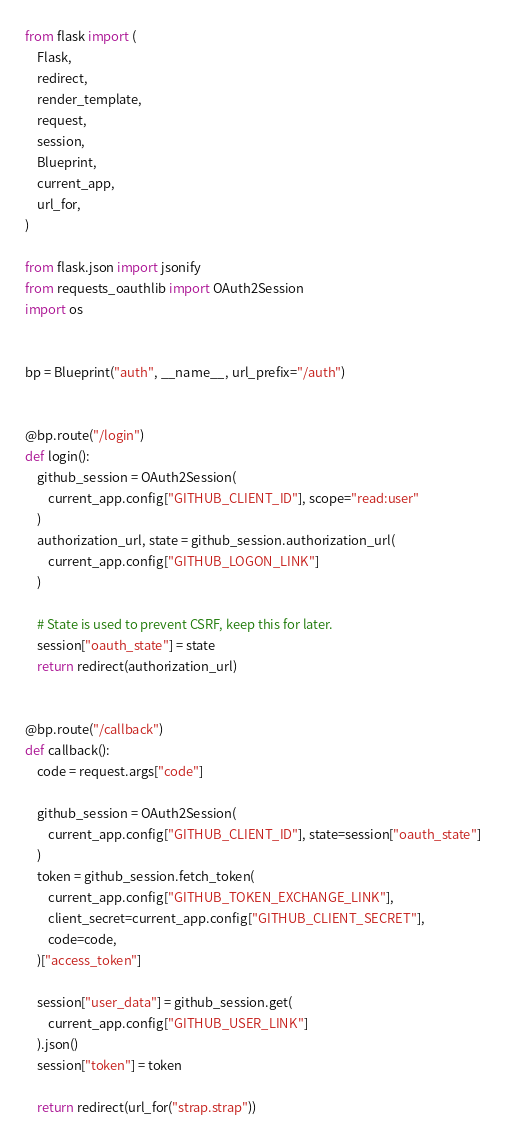<code> <loc_0><loc_0><loc_500><loc_500><_Python_>from flask import (
    Flask,
    redirect,
    render_template,
    request,
    session,
    Blueprint,
    current_app,
    url_for,
)

from flask.json import jsonify
from requests_oauthlib import OAuth2Session
import os


bp = Blueprint("auth", __name__, url_prefix="/auth")


@bp.route("/login")
def login():
    github_session = OAuth2Session(
        current_app.config["GITHUB_CLIENT_ID"], scope="read:user"
    )
    authorization_url, state = github_session.authorization_url(
        current_app.config["GITHUB_LOGON_LINK"]
    )

    # State is used to prevent CSRF, keep this for later.
    session["oauth_state"] = state
    return redirect(authorization_url)


@bp.route("/callback")
def callback():
    code = request.args["code"]

    github_session = OAuth2Session(
        current_app.config["GITHUB_CLIENT_ID"], state=session["oauth_state"]
    )
    token = github_session.fetch_token(
        current_app.config["GITHUB_TOKEN_EXCHANGE_LINK"],
        client_secret=current_app.config["GITHUB_CLIENT_SECRET"],
        code=code,
    )["access_token"]

    session["user_data"] = github_session.get(
        current_app.config["GITHUB_USER_LINK"]
    ).json()
    session["token"] = token

    return redirect(url_for("strap.strap"))
</code> 